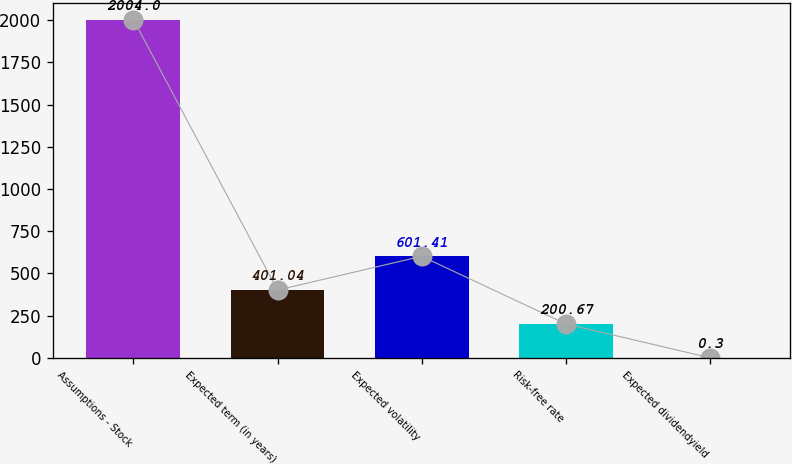Convert chart. <chart><loc_0><loc_0><loc_500><loc_500><bar_chart><fcel>Assumptions - Stock<fcel>Expected term (in years)<fcel>Expected volatility<fcel>Risk-free rate<fcel>Expected dividendyield<nl><fcel>2004<fcel>401.04<fcel>601.41<fcel>200.67<fcel>0.3<nl></chart> 